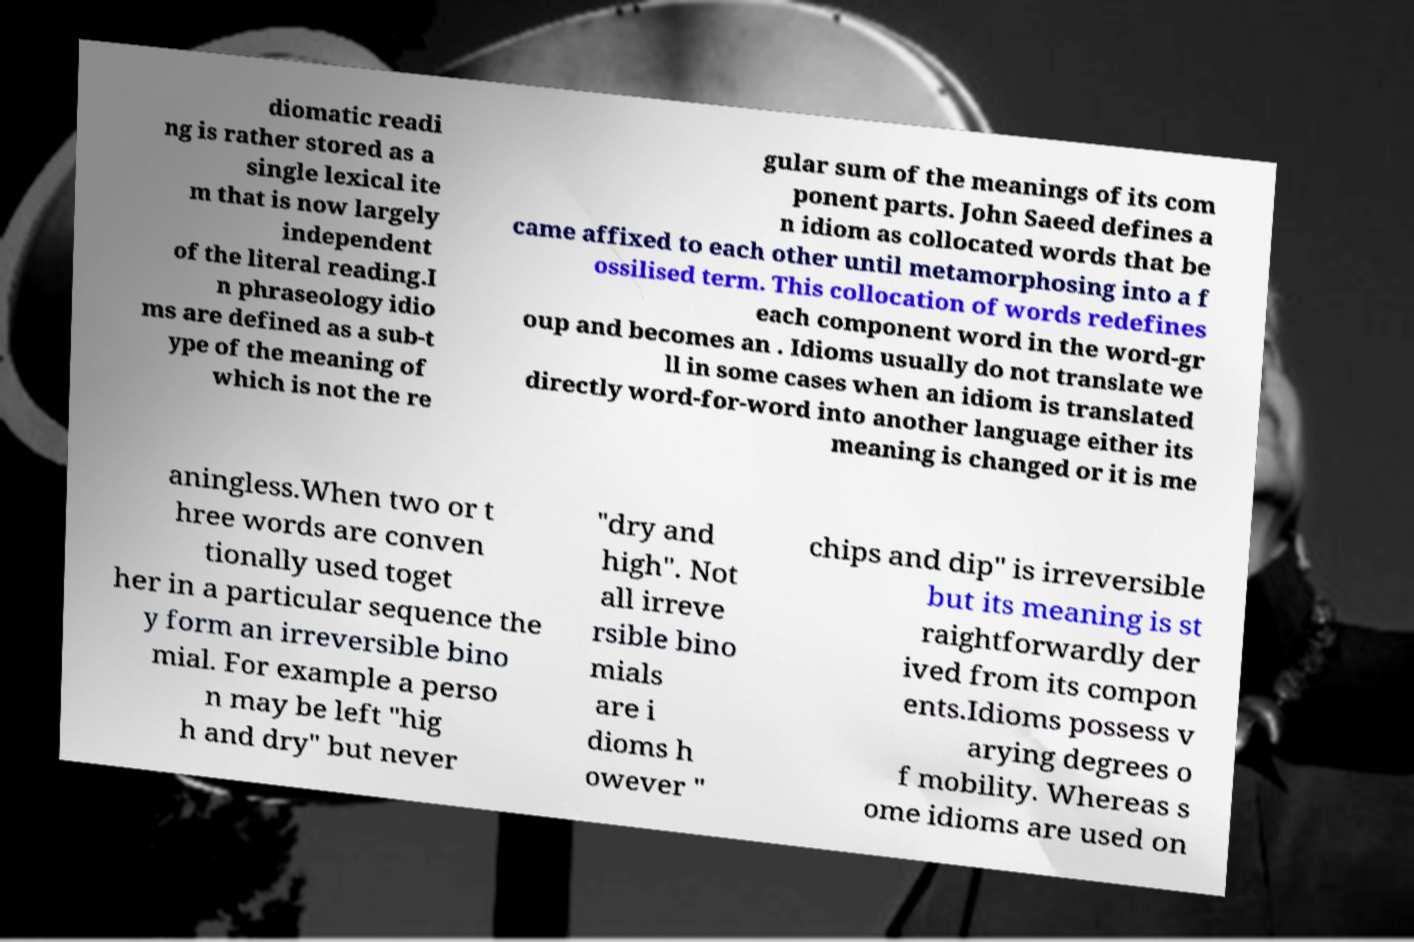Can you accurately transcribe the text from the provided image for me? diomatic readi ng is rather stored as a single lexical ite m that is now largely independent of the literal reading.I n phraseology idio ms are defined as a sub-t ype of the meaning of which is not the re gular sum of the meanings of its com ponent parts. John Saeed defines a n idiom as collocated words that be came affixed to each other until metamorphosing into a f ossilised term. This collocation of words redefines each component word in the word-gr oup and becomes an . Idioms usually do not translate we ll in some cases when an idiom is translated directly word-for-word into another language either its meaning is changed or it is me aningless.When two or t hree words are conven tionally used toget her in a particular sequence the y form an irreversible bino mial. For example a perso n may be left "hig h and dry" but never "dry and high". Not all irreve rsible bino mials are i dioms h owever " chips and dip" is irreversible but its meaning is st raightforwardly der ived from its compon ents.Idioms possess v arying degrees o f mobility. Whereas s ome idioms are used on 